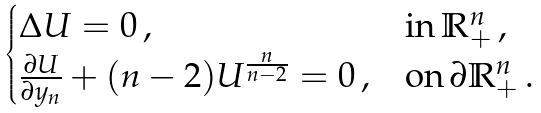Convert formula to latex. <formula><loc_0><loc_0><loc_500><loc_500>\begin{cases} \Delta U = 0 \, , & \text {in} \, \mathbb { R } _ { + } ^ { n } \, , \\ \frac { \partial U } { \partial y _ { n } } + ( n - 2 ) U ^ { \frac { n } { n - 2 } } = 0 \, , & \text {on} \, \partial \mathbb { R } _ { + } ^ { n } \, . \end{cases}</formula> 